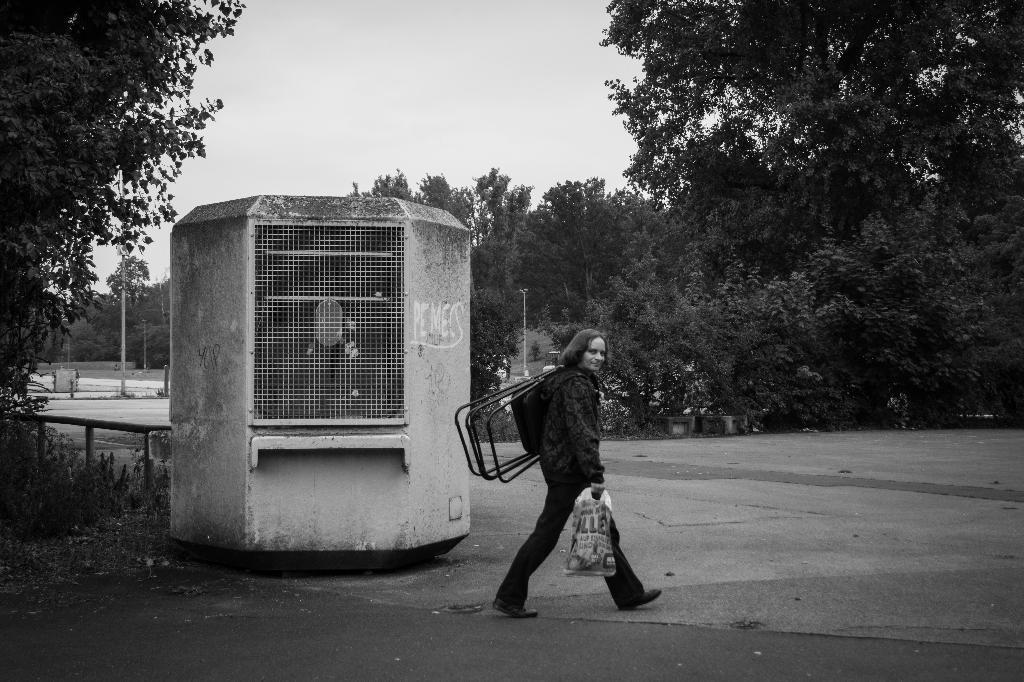Could you give a brief overview of what you see in this image? In this picture we can see a woman wearing black coat, holding the chair in the hand and walking on the road. Behind we can see the white grill tank. In the background we can see some trees. 